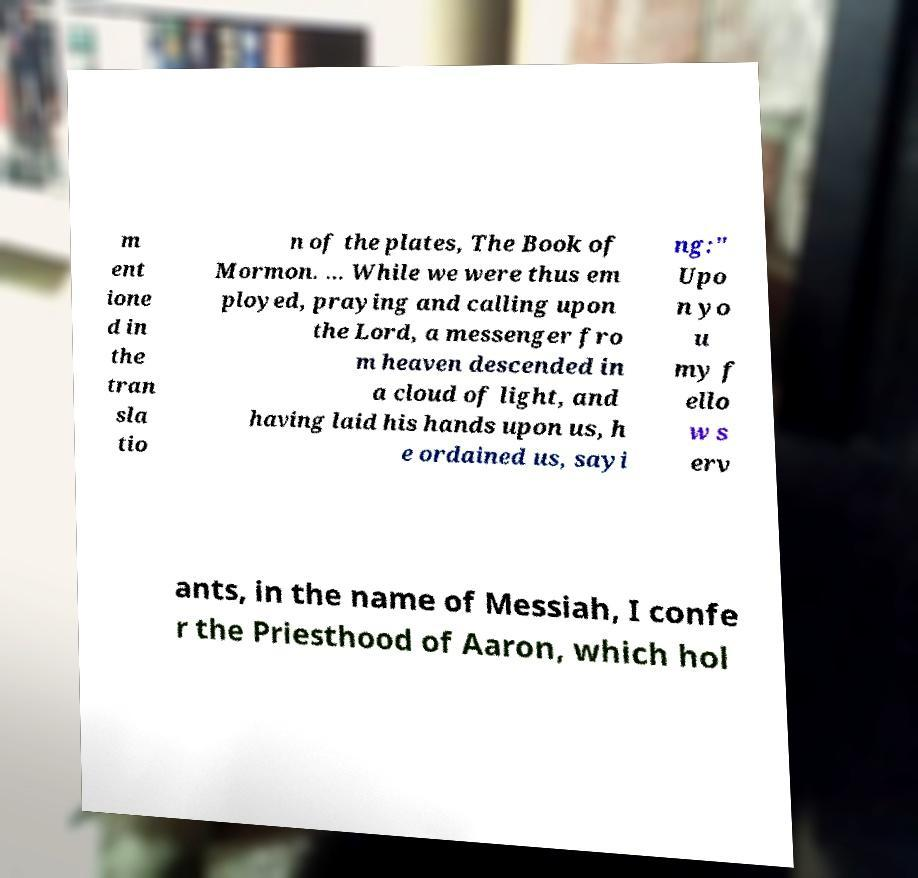Can you accurately transcribe the text from the provided image for me? m ent ione d in the tran sla tio n of the plates, The Book of Mormon. ... While we were thus em ployed, praying and calling upon the Lord, a messenger fro m heaven descended in a cloud of light, and having laid his hands upon us, h e ordained us, sayi ng:" Upo n yo u my f ello w s erv ants, in the name of Messiah, I confe r the Priesthood of Aaron, which hol 